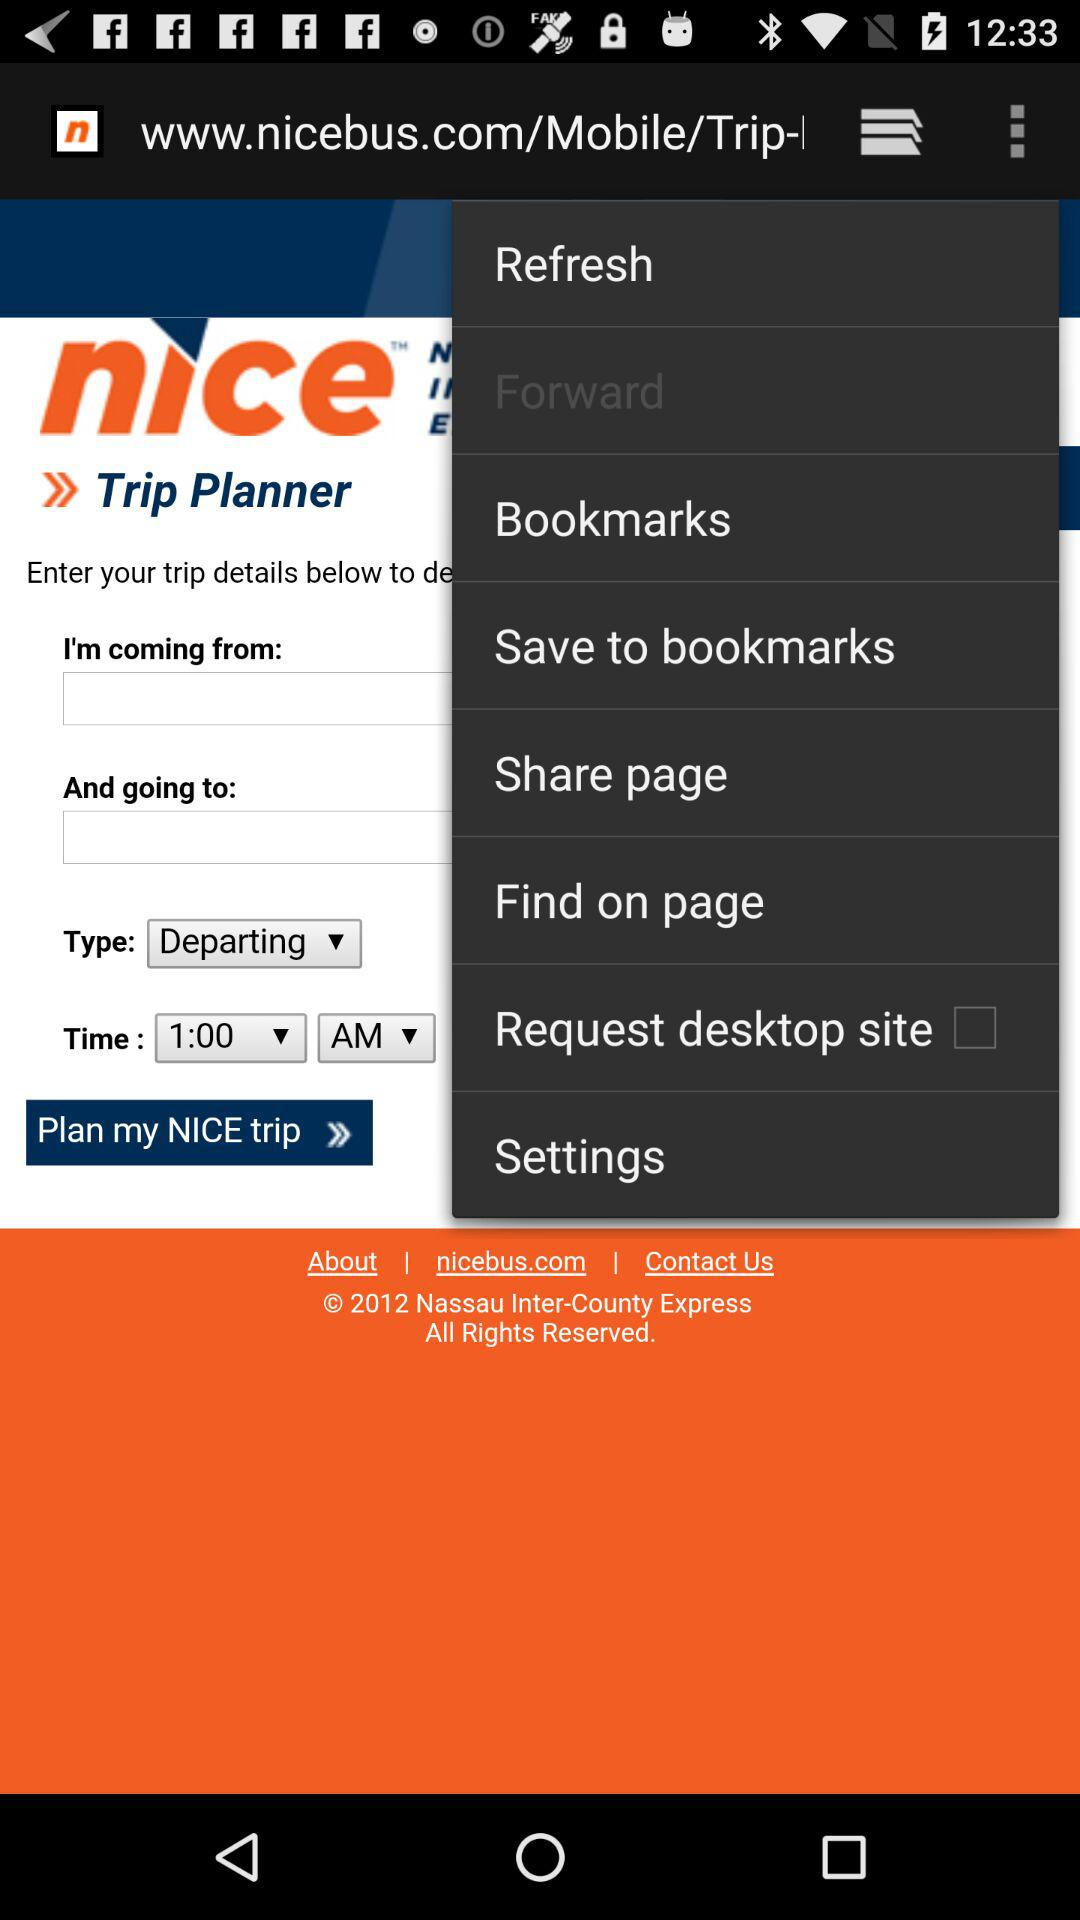How many text inputs are there that are not disabled?
Answer the question using a single word or phrase. 2 